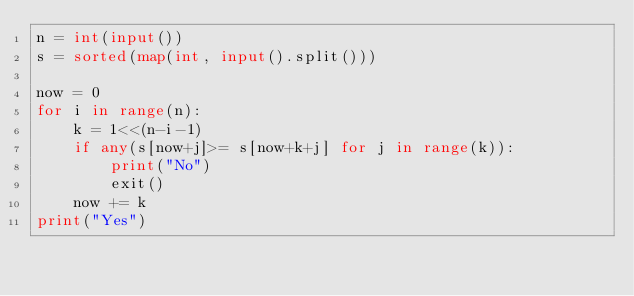Convert code to text. <code><loc_0><loc_0><loc_500><loc_500><_Python_>n = int(input())
s = sorted(map(int, input().split()))

now = 0
for i in range(n):
    k = 1<<(n-i-1)
    if any(s[now+j]>= s[now+k+j] for j in range(k)):
        print("No")
        exit()
    now += k
print("Yes")</code> 